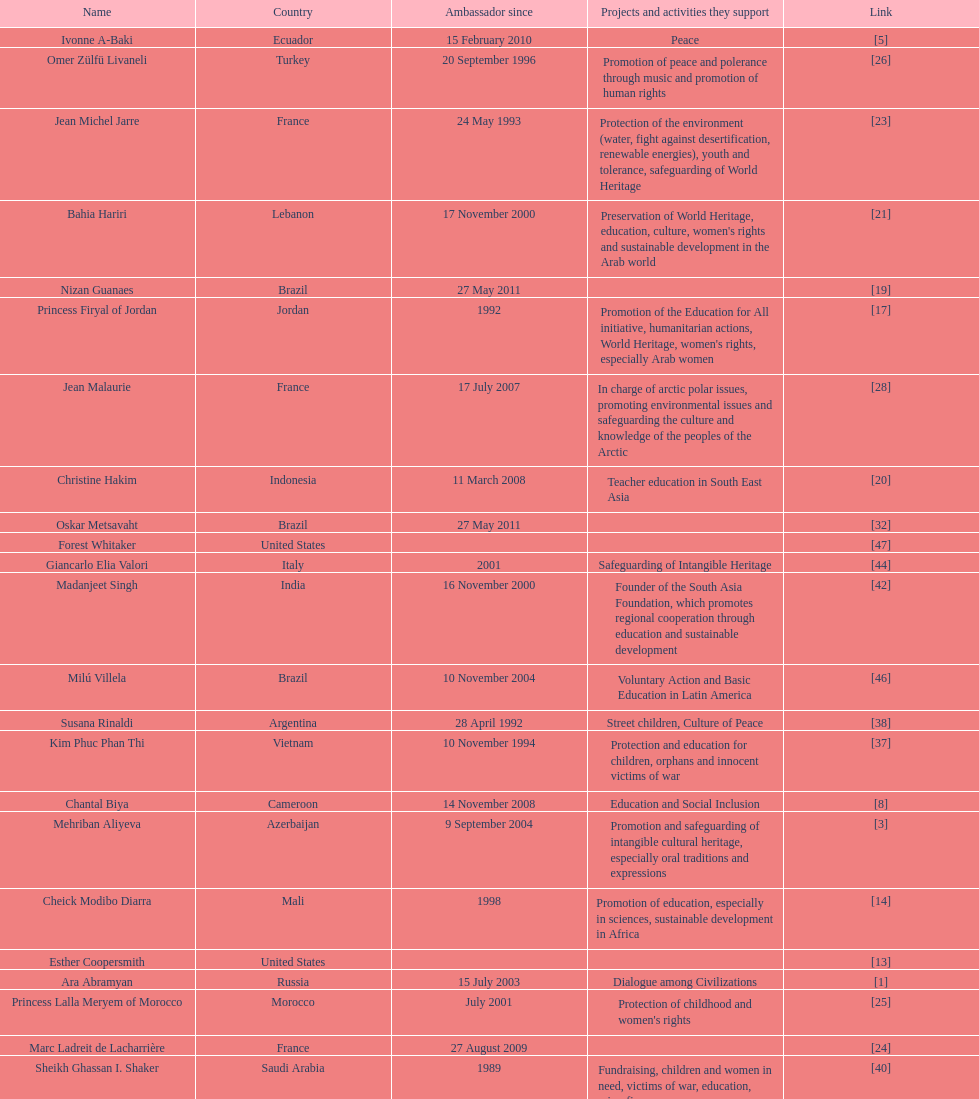Which unesco goodwill ambassador is most known for the promotion of the chernobyl program? Pierre Cardin. 